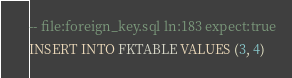<code> <loc_0><loc_0><loc_500><loc_500><_SQL_>-- file:foreign_key.sql ln:183 expect:true
INSERT INTO FKTABLE VALUES (3, 4)
</code> 